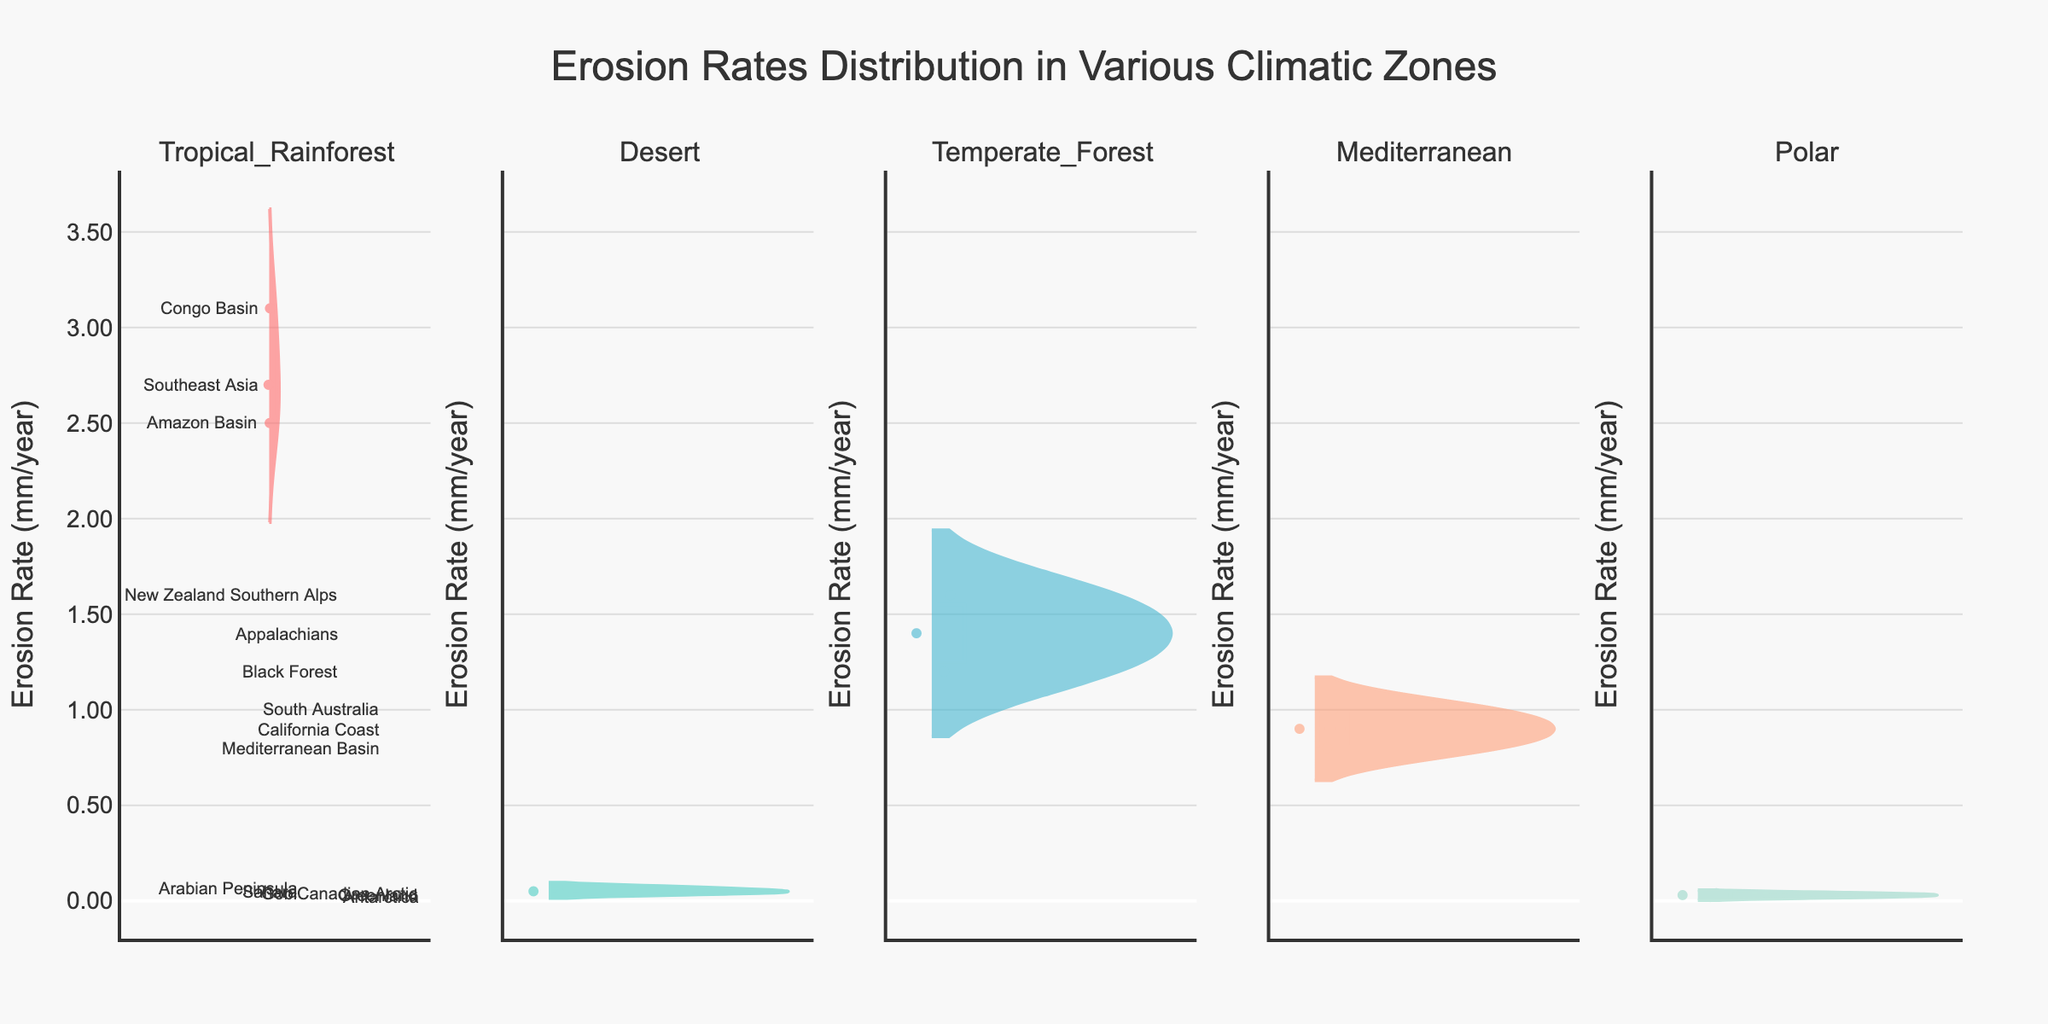How many climatic zones are represented in the chart? The chart shows 5 different violin plots, each representing a unique climatic zone. You can determine this by counting the subplot titles.
Answer: 5 Which climatic zone has the highest mean erosion rate? To determine the highest mean erosion rate, look at the meanlines in each violin plot. The mean lines are visible, and the Tropical Rainforest plot has the highest mean line present.
Answer: Tropical Rainforest What is the median erosion rate in the Mediterranean climatic zone? For the Mediterranean climatic zone, find the red median line inside the violin plot. This red line is at the position corresponding to about 0.9 mm/year.
Answer: 0.9 mm/year How do erosion rates in the Desert zone compare to those in the Tropical Rainforest zone? The Desert Zone shows significantly lower erosion rates, all falling under 0.1 mm/year, while the Tropical Rainforest zone has much higher erosion rates, ranging from 2.5 to 3.1 mm/year.
Answer: Lower in Desert Which location has the lowest erosion rate in the Polar climatic zone? In the Polar climatic zone, compare the individual data points. The lowest data point corresponds to Antarctica with an erosion rate of 0.02 mm/year.
Answer: Antarctica What is the range of erosion rates in the Temperate Forest climatic zone? Look at the top and bottom ends of the violin plot for the Temperate Forest zone. The highest value is about 1.6 mm/year and the lowest is around 1.2 mm/year, so the range is 1.6 - 1.2 = 0.4 mm/year.
Answer: 0.4 mm/year Which climatic zone has the least variation in erosion rates, and how do you know? The Desert climatic zone has the least variation in its violin plot width, suggesting minimum spread. All data points are clustered very close to 0.05 mm/year.
Answer: Desert Are there any outliers in the erosion rates for the Polar climatic zone? No outliers are visible in the Polar zone as all data points are very close to each other within about 0.02 to 0.04 mm/year, with no solitary points far from the central cluster.
Answer: No Which location has the highest erosion rate in the Tropical Rainforest zone, and what is its value? In the Tropical Rainforest zone, the highest data point corresponds to the Congo Basin, with an erosion rate of 3.1 mm/year.
Answer: Congo Basin Compare the spread of erosion rates between the Mediterranean and Temperate Forest climatic zones. The Mediterranean zone shows less spread with a range of 0.8 to 1.0 mm/year, while the Temperate Forest zone has a wider spread of 1.2 to 1.6 mm/year. The wider the violin plot, the greater the spread.
Answer: Wider in Temperate Forest 